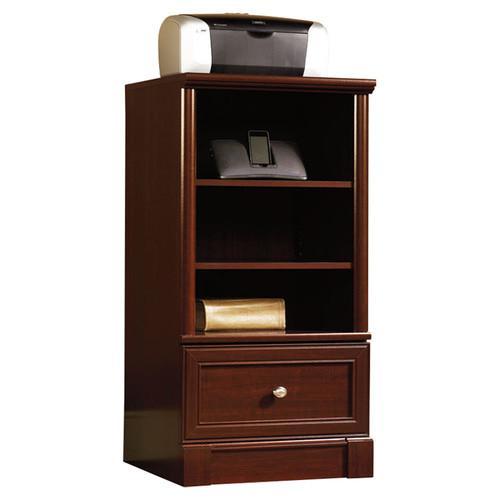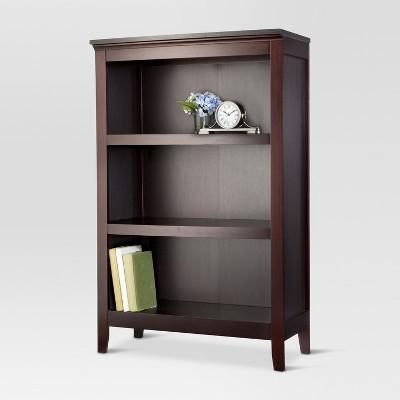The first image is the image on the left, the second image is the image on the right. Analyze the images presented: Is the assertion "In one image, a bookcase has a drawer in addition to open shelving." valid? Answer yes or no. Yes. 